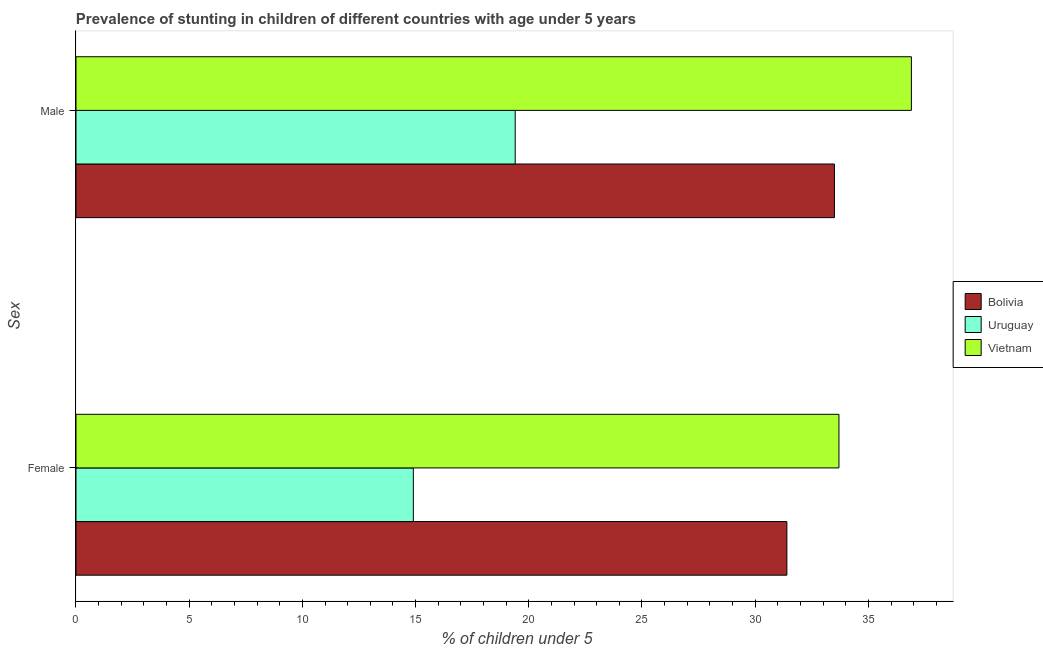Are the number of bars per tick equal to the number of legend labels?
Provide a succinct answer. Yes. Are the number of bars on each tick of the Y-axis equal?
Keep it short and to the point. Yes. How many bars are there on the 1st tick from the top?
Make the answer very short. 3. How many bars are there on the 2nd tick from the bottom?
Ensure brevity in your answer.  3. What is the percentage of stunted female children in Uruguay?
Make the answer very short. 14.9. Across all countries, what is the maximum percentage of stunted female children?
Offer a terse response. 33.7. Across all countries, what is the minimum percentage of stunted female children?
Your answer should be very brief. 14.9. In which country was the percentage of stunted male children maximum?
Provide a succinct answer. Vietnam. In which country was the percentage of stunted male children minimum?
Your answer should be compact. Uruguay. What is the total percentage of stunted male children in the graph?
Offer a terse response. 89.8. What is the difference between the percentage of stunted male children in Uruguay and that in Vietnam?
Your response must be concise. -17.5. What is the difference between the percentage of stunted female children in Vietnam and the percentage of stunted male children in Bolivia?
Keep it short and to the point. 0.2. What is the average percentage of stunted male children per country?
Ensure brevity in your answer.  29.93. What is the difference between the percentage of stunted female children and percentage of stunted male children in Bolivia?
Keep it short and to the point. -2.1. In how many countries, is the percentage of stunted female children greater than 32 %?
Provide a succinct answer. 1. What is the ratio of the percentage of stunted female children in Uruguay to that in Vietnam?
Provide a succinct answer. 0.44. Is the percentage of stunted male children in Bolivia less than that in Vietnam?
Give a very brief answer. Yes. What does the 2nd bar from the top in Male represents?
Provide a succinct answer. Uruguay. What does the 3rd bar from the bottom in Female represents?
Keep it short and to the point. Vietnam. How many bars are there?
Ensure brevity in your answer.  6. Are all the bars in the graph horizontal?
Your answer should be compact. Yes. What is the difference between two consecutive major ticks on the X-axis?
Your response must be concise. 5. Does the graph contain grids?
Ensure brevity in your answer.  No. Where does the legend appear in the graph?
Offer a very short reply. Center right. How are the legend labels stacked?
Offer a very short reply. Vertical. What is the title of the graph?
Your answer should be very brief. Prevalence of stunting in children of different countries with age under 5 years. Does "Kosovo" appear as one of the legend labels in the graph?
Provide a succinct answer. No. What is the label or title of the X-axis?
Your answer should be compact.  % of children under 5. What is the label or title of the Y-axis?
Provide a succinct answer. Sex. What is the  % of children under 5 in Bolivia in Female?
Your answer should be compact. 31.4. What is the  % of children under 5 in Uruguay in Female?
Keep it short and to the point. 14.9. What is the  % of children under 5 of Vietnam in Female?
Provide a succinct answer. 33.7. What is the  % of children under 5 of Bolivia in Male?
Offer a very short reply. 33.5. What is the  % of children under 5 of Uruguay in Male?
Provide a short and direct response. 19.4. What is the  % of children under 5 of Vietnam in Male?
Provide a succinct answer. 36.9. Across all Sex, what is the maximum  % of children under 5 in Bolivia?
Offer a very short reply. 33.5. Across all Sex, what is the maximum  % of children under 5 in Uruguay?
Keep it short and to the point. 19.4. Across all Sex, what is the maximum  % of children under 5 of Vietnam?
Offer a terse response. 36.9. Across all Sex, what is the minimum  % of children under 5 in Bolivia?
Ensure brevity in your answer.  31.4. Across all Sex, what is the minimum  % of children under 5 of Uruguay?
Give a very brief answer. 14.9. Across all Sex, what is the minimum  % of children under 5 in Vietnam?
Keep it short and to the point. 33.7. What is the total  % of children under 5 of Bolivia in the graph?
Offer a very short reply. 64.9. What is the total  % of children under 5 of Uruguay in the graph?
Your response must be concise. 34.3. What is the total  % of children under 5 in Vietnam in the graph?
Make the answer very short. 70.6. What is the difference between the  % of children under 5 in Bolivia in Female and that in Male?
Give a very brief answer. -2.1. What is the difference between the  % of children under 5 in Vietnam in Female and that in Male?
Offer a terse response. -3.2. What is the average  % of children under 5 in Bolivia per Sex?
Offer a very short reply. 32.45. What is the average  % of children under 5 of Uruguay per Sex?
Your response must be concise. 17.15. What is the average  % of children under 5 of Vietnam per Sex?
Ensure brevity in your answer.  35.3. What is the difference between the  % of children under 5 of Bolivia and  % of children under 5 of Uruguay in Female?
Offer a terse response. 16.5. What is the difference between the  % of children under 5 of Bolivia and  % of children under 5 of Vietnam in Female?
Give a very brief answer. -2.3. What is the difference between the  % of children under 5 in Uruguay and  % of children under 5 in Vietnam in Female?
Offer a very short reply. -18.8. What is the difference between the  % of children under 5 of Uruguay and  % of children under 5 of Vietnam in Male?
Provide a short and direct response. -17.5. What is the ratio of the  % of children under 5 of Bolivia in Female to that in Male?
Ensure brevity in your answer.  0.94. What is the ratio of the  % of children under 5 of Uruguay in Female to that in Male?
Ensure brevity in your answer.  0.77. What is the ratio of the  % of children under 5 of Vietnam in Female to that in Male?
Keep it short and to the point. 0.91. What is the difference between the highest and the second highest  % of children under 5 in Bolivia?
Your answer should be compact. 2.1. What is the difference between the highest and the second highest  % of children under 5 of Vietnam?
Offer a very short reply. 3.2. What is the difference between the highest and the lowest  % of children under 5 in Bolivia?
Offer a terse response. 2.1. 